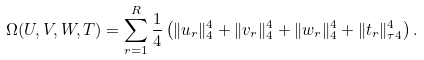Convert formula to latex. <formula><loc_0><loc_0><loc_500><loc_500>\Omega ( U , V , W , T ) = \sum _ { r = 1 } ^ { R } \frac { 1 } { 4 } \left ( \| u _ { r } \| _ { 4 } ^ { 4 } + \| v _ { r } \| _ { 4 } ^ { 4 } + \| w _ { r } \| _ { 4 } ^ { 4 } + \| t _ { r } \| _ { \tau 4 } ^ { 4 } \right ) .</formula> 